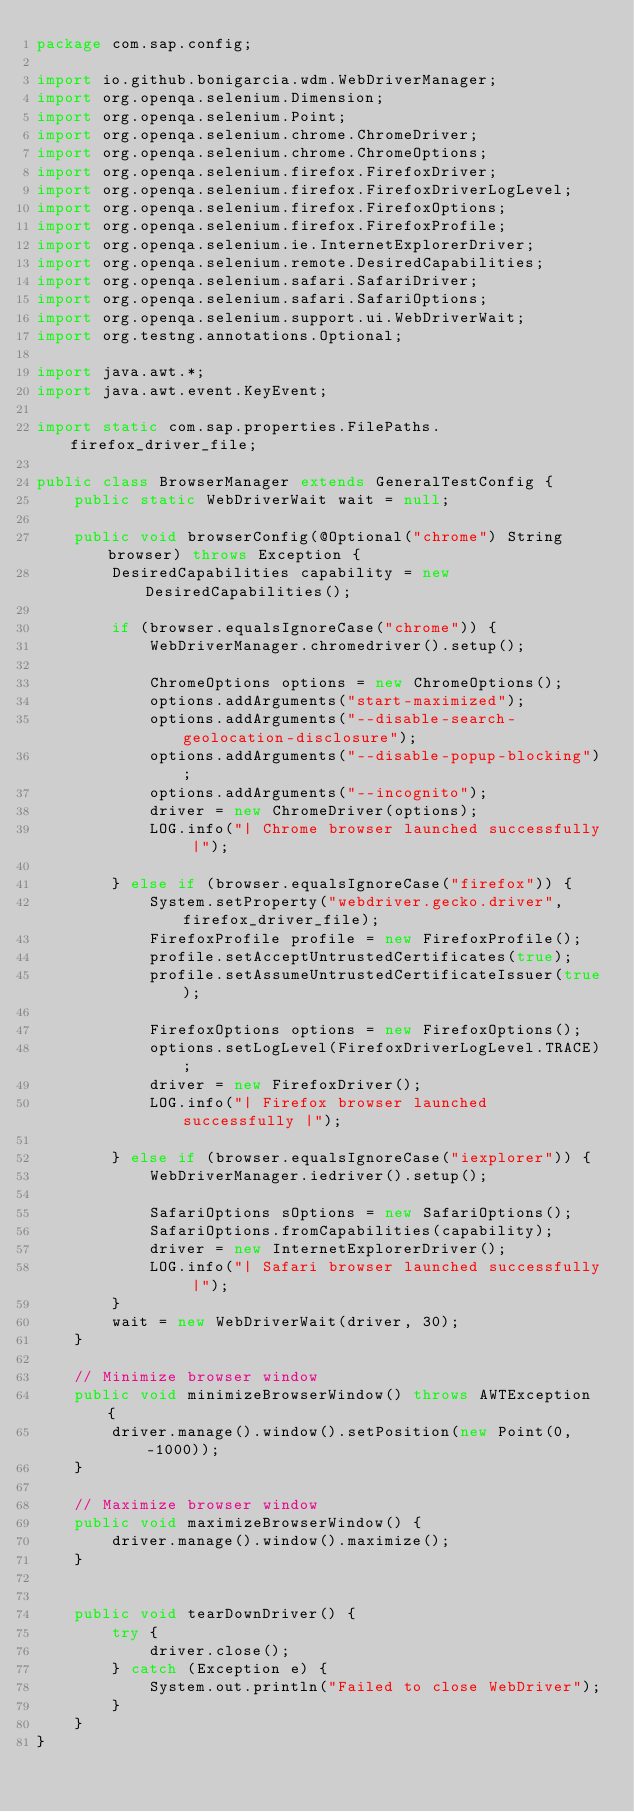<code> <loc_0><loc_0><loc_500><loc_500><_Java_>package com.sap.config;

import io.github.bonigarcia.wdm.WebDriverManager;
import org.openqa.selenium.Dimension;
import org.openqa.selenium.Point;
import org.openqa.selenium.chrome.ChromeDriver;
import org.openqa.selenium.chrome.ChromeOptions;
import org.openqa.selenium.firefox.FirefoxDriver;
import org.openqa.selenium.firefox.FirefoxDriverLogLevel;
import org.openqa.selenium.firefox.FirefoxOptions;
import org.openqa.selenium.firefox.FirefoxProfile;
import org.openqa.selenium.ie.InternetExplorerDriver;
import org.openqa.selenium.remote.DesiredCapabilities;
import org.openqa.selenium.safari.SafariDriver;
import org.openqa.selenium.safari.SafariOptions;
import org.openqa.selenium.support.ui.WebDriverWait;
import org.testng.annotations.Optional;

import java.awt.*;
import java.awt.event.KeyEvent;

import static com.sap.properties.FilePaths.firefox_driver_file;

public class BrowserManager extends GeneralTestConfig {
    public static WebDriverWait wait = null;

    public void browserConfig(@Optional("chrome") String browser) throws Exception {
        DesiredCapabilities capability = new DesiredCapabilities();

        if (browser.equalsIgnoreCase("chrome")) {
            WebDriverManager.chromedriver().setup();

            ChromeOptions options = new ChromeOptions();
            options.addArguments("start-maximized");
            options.addArguments("--disable-search-geolocation-disclosure");
            options.addArguments("--disable-popup-blocking");
            options.addArguments("--incognito");
            driver = new ChromeDriver(options);
            LOG.info("| Chrome browser launched successfully |");

        } else if (browser.equalsIgnoreCase("firefox")) {
            System.setProperty("webdriver.gecko.driver", firefox_driver_file);
            FirefoxProfile profile = new FirefoxProfile();
            profile.setAcceptUntrustedCertificates(true);
            profile.setAssumeUntrustedCertificateIssuer(true);

            FirefoxOptions options = new FirefoxOptions();
            options.setLogLevel(FirefoxDriverLogLevel.TRACE);
            driver = new FirefoxDriver();
            LOG.info("| Firefox browser launched successfully |");

        } else if (browser.equalsIgnoreCase("iexplorer")) {
            WebDriverManager.iedriver().setup();

            SafariOptions sOptions = new SafariOptions();
            SafariOptions.fromCapabilities(capability);
            driver = new InternetExplorerDriver();
            LOG.info("| Safari browser launched successfully |");
        }
        wait = new WebDriverWait(driver, 30);
    }

    // Minimize browser window
    public void minimizeBrowserWindow() throws AWTException {
        driver.manage().window().setPosition(new Point(0, -1000));
    }

    // Maximize browser window
    public void maximizeBrowserWindow() {
        driver.manage().window().maximize();
    }


    public void tearDownDriver() {
        try {
            driver.close();
        } catch (Exception e) {
            System.out.println("Failed to close WebDriver");
        }
    }
}
</code> 